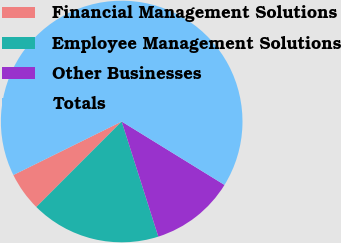Convert chart to OTSL. <chart><loc_0><loc_0><loc_500><loc_500><pie_chart><fcel>Financial Management Solutions<fcel>Employee Management Solutions<fcel>Other Businesses<fcel>Totals<nl><fcel>5.21%<fcel>17.39%<fcel>11.3%<fcel>66.09%<nl></chart> 